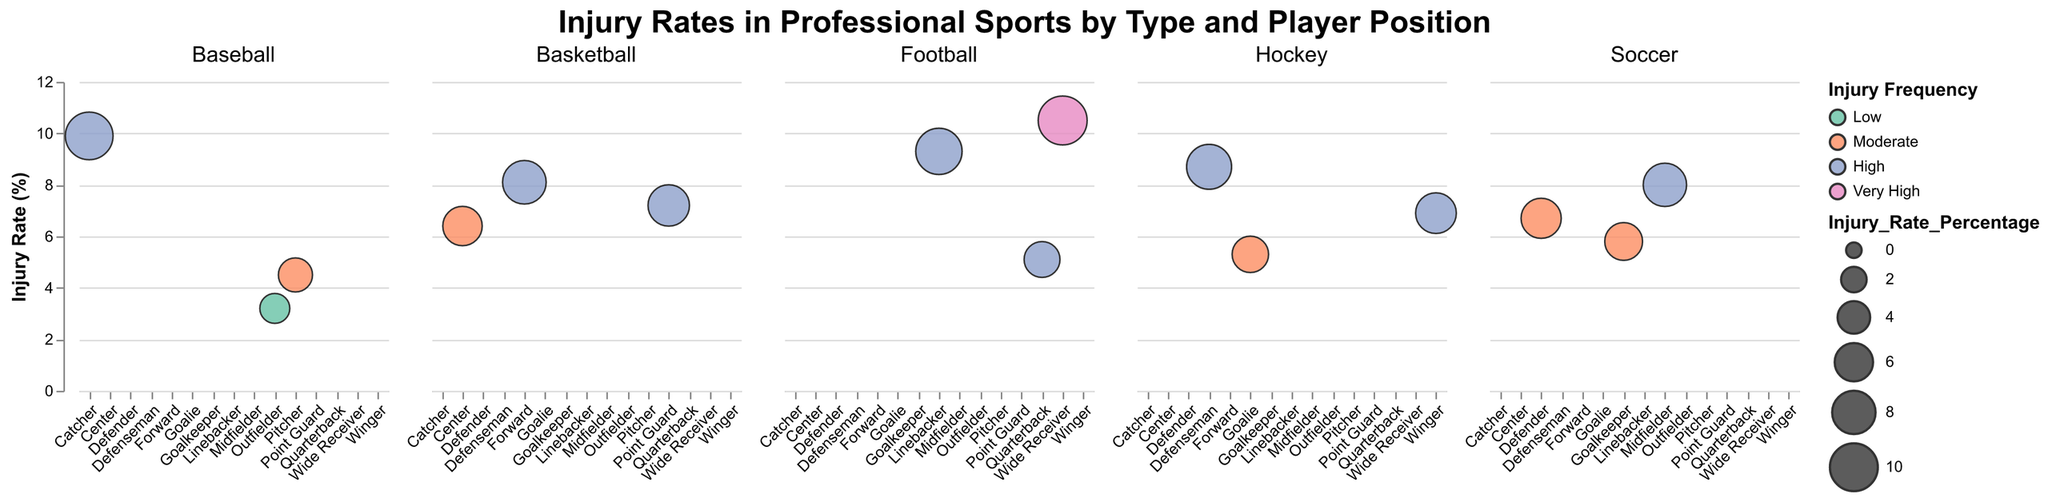What sport and position has the highest injury rate? The figure shows that the Football Wide Receiver has an injury rate percentage of 10.5, which is the highest in the dataset.
Answer: Football Wide Receiver How does the injury rate of Soccer Midfielders compare to Soccer Defenders? Soccer Midfielders have an injury rate percentage of 8.0, while Soccer Defenders have an injury rate percentage of 6.7. Therefore, Midfielders have a higher injury rate compared to Defenders.
Answer: Midfielders have a higher injury rate Which basketball position has the highest injury rate? The figure indicates that the Forward position in Basketball has the highest injury rate percentage of 8.1 among all Basketball positions.
Answer: Forward What is the severity of injuries for Baseball Catchers? Looking at the tooltip information in the figure, Baseball Catchers have a Severe injury severity.
Answer: Severe Compare the injury frequencies of Football Linebackers and Hockey Defensemen. Both Football Linebackers and Hockey Defensemen have a High injury frequency, as depicted by the same color coding in the figure.
Answer: Both have High injury frequency Which Hockey position has a lower injury rate, Goalie or Winger? The figure shows that Hockey Goalies have an injury rate percentage of 5.3, while Hockey Wingers have an injury rate percentage of 6.9. Therefore, Hockey Goalies have a lower injury rate.
Answer: Hockey Goalie What color represents a 'Moderate' injury frequency and which sport positions fall under this category? The color representing 'Moderate' injury frequency is the second color from the left in the legend, which is a pinkish hue. According to the figure, the positions with a 'Moderate' injury frequency are Basketball Center, Baseball Pitcher, Soccer Goalkeeper, Soccer Defender, Hockey Goalie.
Answer: Pinkish hue; Basketball Center, Baseball Pitcher, Soccer Goalkeeper, Soccer Defender, Hockey Goalie Among positions with 'High' injury frequency, which has the lowest injury rate? Looking at the 'High' frequency positions and comparing their injury rate percentages, the Point Guard position in Basketball has an injury rate of 7.2%, which is the lowest.
Answer: Basketball Point Guard What sport has the most variance in injury severity across positions? Observing the severity levels within each sport, Football shows both Moderate and Severe in its player positions, while others show less variance.
Answer: Football 